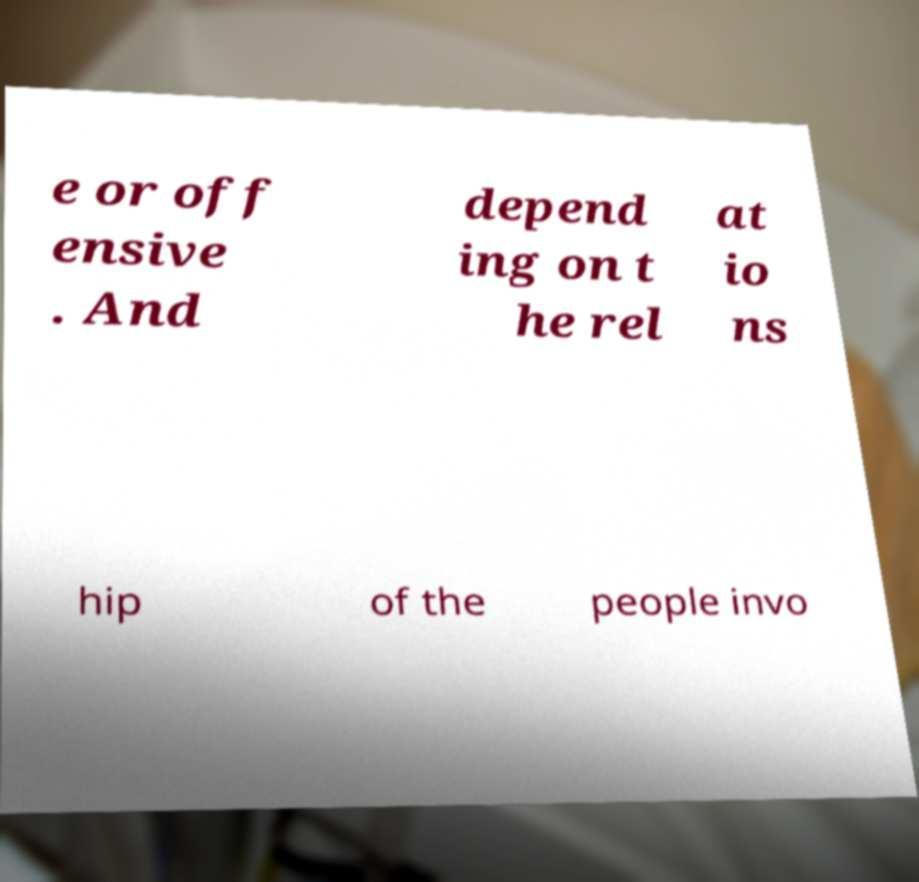Can you accurately transcribe the text from the provided image for me? e or off ensive . And depend ing on t he rel at io ns hip of the people invo 